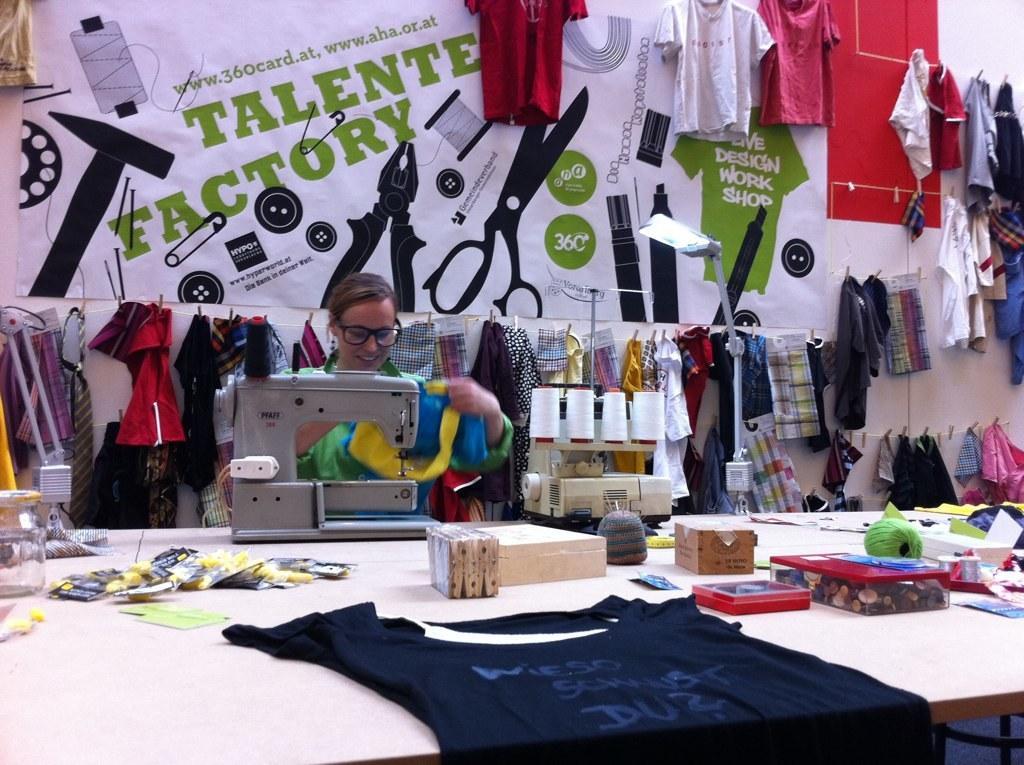Describe this image in one or two sentences. In this picture in the center we can see a woman stitching clothes. In the background there is a banner written talented factory and few tools on the banner. And there are few clothes hanging in the center of the of image and to the left of the image and right also. In the center the woman is smiling. In foreground there is a table, on the table there is cloth in blue color there is a stitching machine, threads, light, wool, box and small cut pieces and a jar also. 